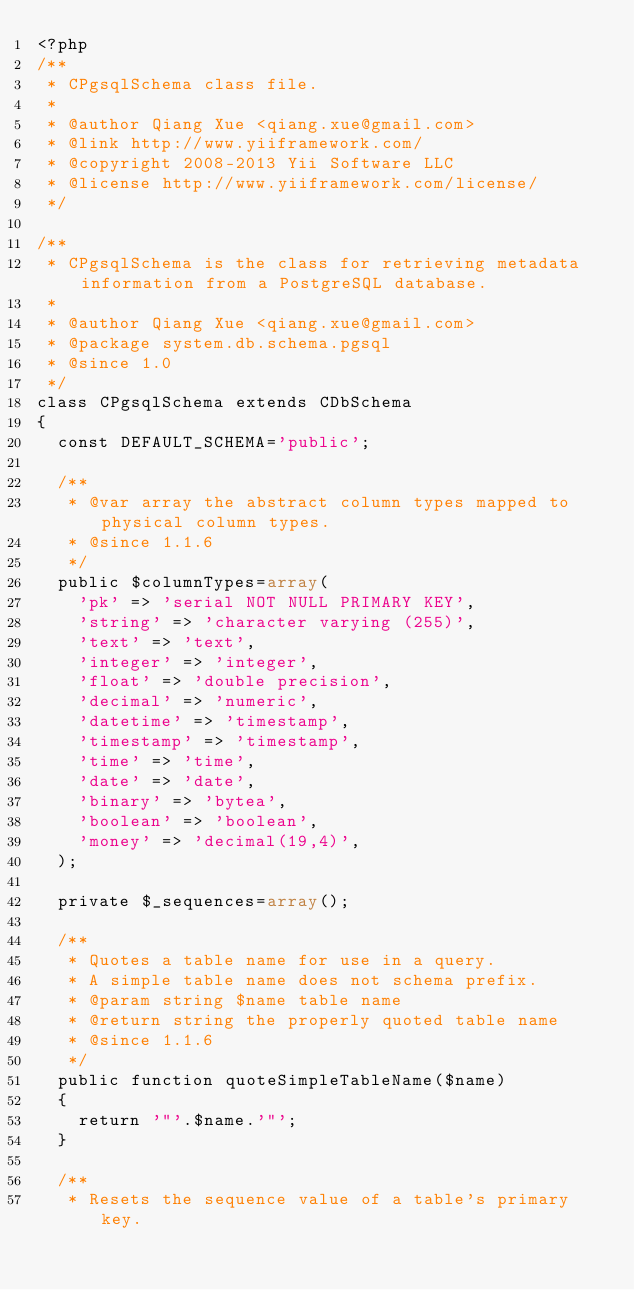Convert code to text. <code><loc_0><loc_0><loc_500><loc_500><_PHP_><?php
/**
 * CPgsqlSchema class file.
 *
 * @author Qiang Xue <qiang.xue@gmail.com>
 * @link http://www.yiiframework.com/
 * @copyright 2008-2013 Yii Software LLC
 * @license http://www.yiiframework.com/license/
 */

/**
 * CPgsqlSchema is the class for retrieving metadata information from a PostgreSQL database.
 *
 * @author Qiang Xue <qiang.xue@gmail.com>
 * @package system.db.schema.pgsql
 * @since 1.0
 */
class CPgsqlSchema extends CDbSchema
{
	const DEFAULT_SCHEMA='public';

	/**
	 * @var array the abstract column types mapped to physical column types.
	 * @since 1.1.6
	 */
	public $columnTypes=array(
		'pk' => 'serial NOT NULL PRIMARY KEY',
		'string' => 'character varying (255)',
		'text' => 'text',
		'integer' => 'integer',
		'float' => 'double precision',
		'decimal' => 'numeric',
		'datetime' => 'timestamp',
		'timestamp' => 'timestamp',
		'time' => 'time',
		'date' => 'date',
		'binary' => 'bytea',
		'boolean' => 'boolean',
		'money' => 'decimal(19,4)',
	);

	private $_sequences=array();

	/**
	 * Quotes a table name for use in a query.
	 * A simple table name does not schema prefix.
	 * @param string $name table name
	 * @return string the properly quoted table name
	 * @since 1.1.6
	 */
	public function quoteSimpleTableName($name)
	{
		return '"'.$name.'"';
	}

	/**
	 * Resets the sequence value of a table's primary key.</code> 